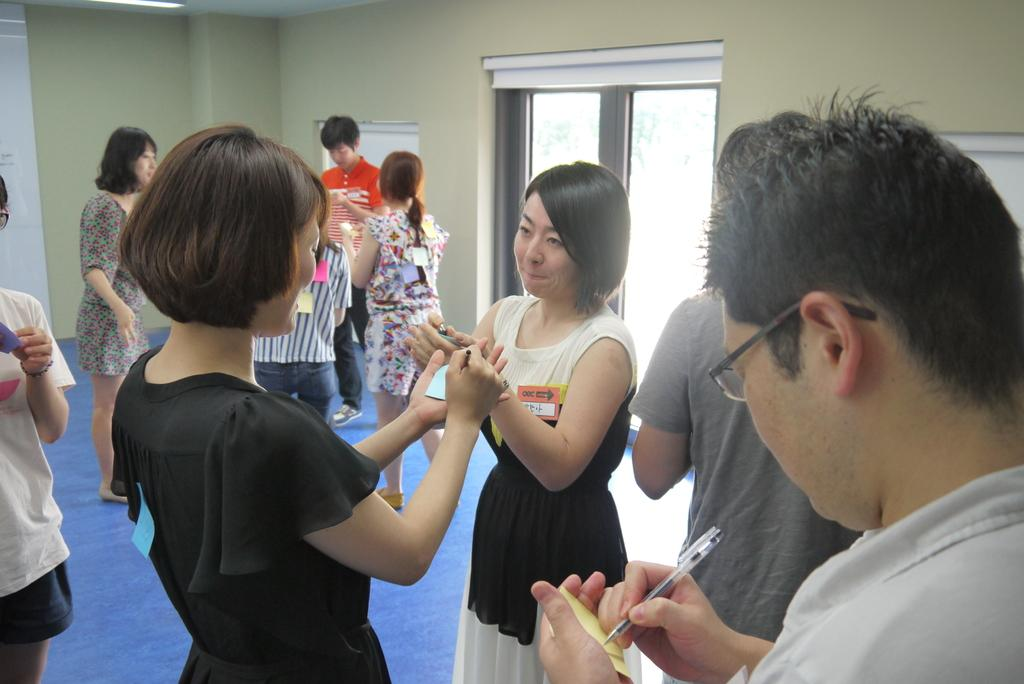What are the people in the image doing? The people in the image are standing in the center and writing on sticky notes. What can be seen in the background of the image? There is a door and a wall in the background of the image. What type of waves can be seen crashing on the shore in the image? There are no waves or shore visible in the image; it features people writing on sticky notes with a door and a wall in the background. 